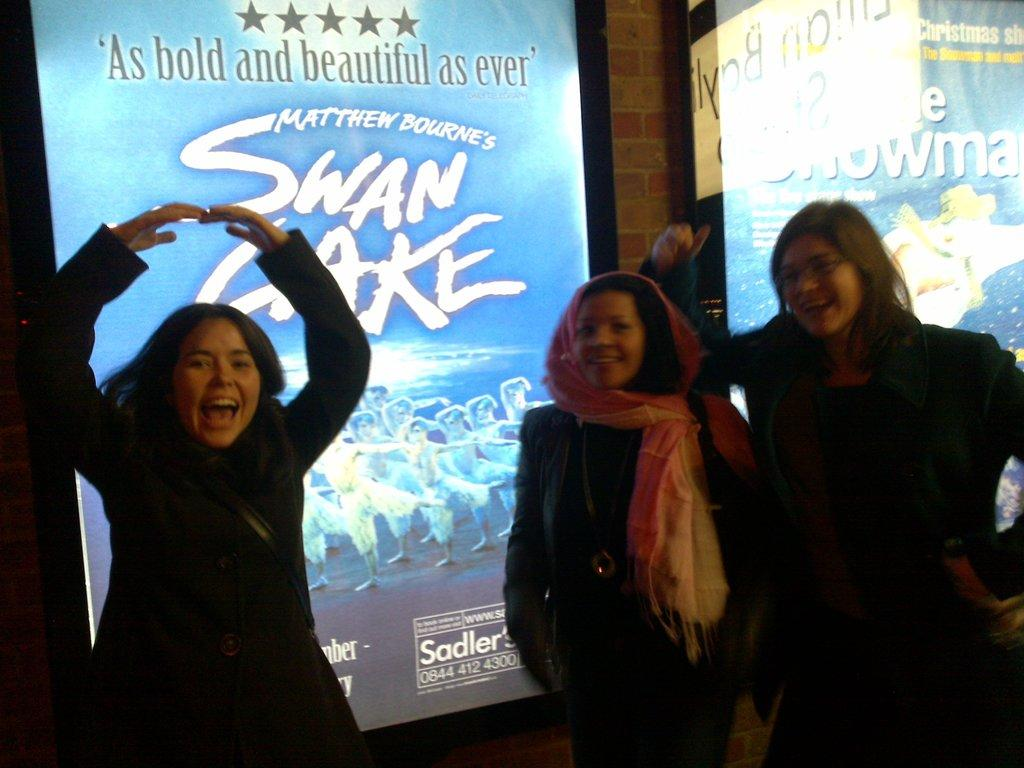What is located in the foreground of the image? There are people in the foreground of the image. What can be seen in the background of the image? There are screens in the background of the image. What is the limit of money that can be seen on the screens in the image? There is no mention of money or limits on the screens in the image; they are simply screens. 